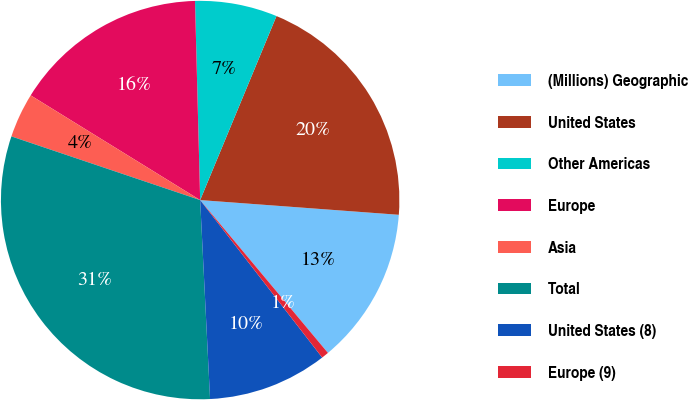<chart> <loc_0><loc_0><loc_500><loc_500><pie_chart><fcel>(Millions) Geographic<fcel>United States<fcel>Other Americas<fcel>Europe<fcel>Asia<fcel>Total<fcel>United States (8)<fcel>Europe (9)<nl><fcel>12.74%<fcel>19.92%<fcel>6.67%<fcel>15.78%<fcel>3.63%<fcel>30.97%<fcel>9.7%<fcel>0.59%<nl></chart> 